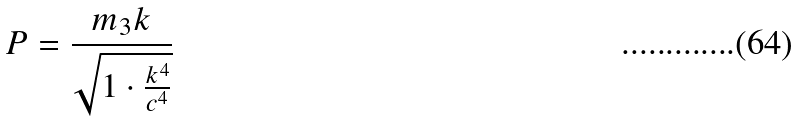<formula> <loc_0><loc_0><loc_500><loc_500>P = \frac { m _ { 3 } k } { \sqrt { 1 \cdot \frac { k ^ { 4 } } { c ^ { 4 } } } }</formula> 